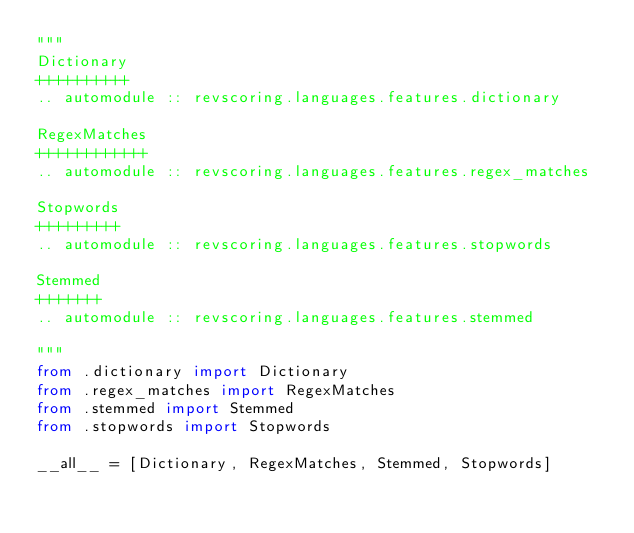Convert code to text. <code><loc_0><loc_0><loc_500><loc_500><_Python_>"""
Dictionary
++++++++++
.. automodule :: revscoring.languages.features.dictionary

RegexMatches
++++++++++++
.. automodule :: revscoring.languages.features.regex_matches

Stopwords
+++++++++
.. automodule :: revscoring.languages.features.stopwords

Stemmed
+++++++
.. automodule :: revscoring.languages.features.stemmed

"""
from .dictionary import Dictionary
from .regex_matches import RegexMatches
from .stemmed import Stemmed
from .stopwords import Stopwords

__all__ = [Dictionary, RegexMatches, Stemmed, Stopwords]
</code> 